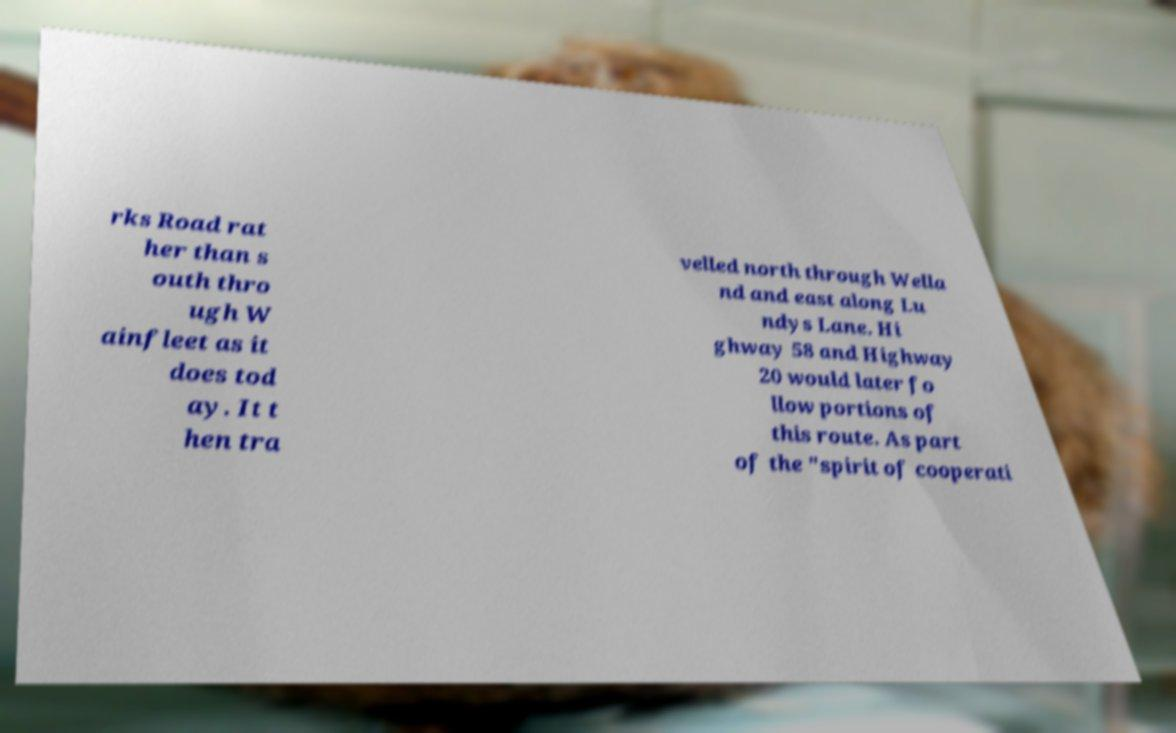Please identify and transcribe the text found in this image. rks Road rat her than s outh thro ugh W ainfleet as it does tod ay. It t hen tra velled north through Wella nd and east along Lu ndys Lane. Hi ghway 58 and Highway 20 would later fo llow portions of this route. As part of the "spirit of cooperati 